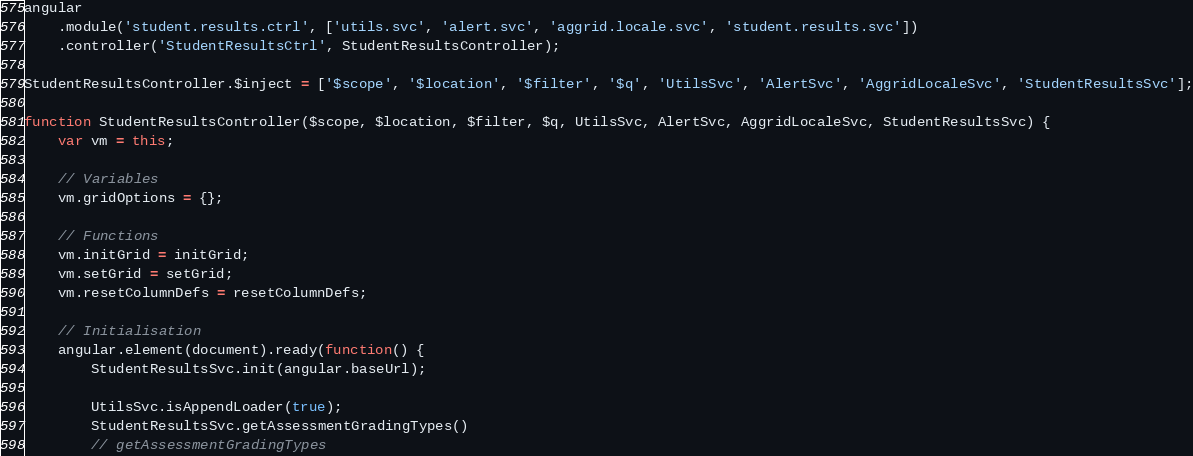<code> <loc_0><loc_0><loc_500><loc_500><_JavaScript_>angular
    .module('student.results.ctrl', ['utils.svc', 'alert.svc', 'aggrid.locale.svc', 'student.results.svc'])
    .controller('StudentResultsCtrl', StudentResultsController);

StudentResultsController.$inject = ['$scope', '$location', '$filter', '$q', 'UtilsSvc', 'AlertSvc', 'AggridLocaleSvc', 'StudentResultsSvc'];

function StudentResultsController($scope, $location, $filter, $q, UtilsSvc, AlertSvc, AggridLocaleSvc, StudentResultsSvc) {
	var vm = this;

    // Variables
    vm.gridOptions = {};

    // Functions
    vm.initGrid = initGrid;
    vm.setGrid = setGrid;
    vm.resetColumnDefs = resetColumnDefs;

    // Initialisation
    angular.element(document).ready(function() {
        StudentResultsSvc.init(angular.baseUrl);

        UtilsSvc.isAppendLoader(true);
        StudentResultsSvc.getAssessmentGradingTypes()
        // getAssessmentGradingTypes</code> 